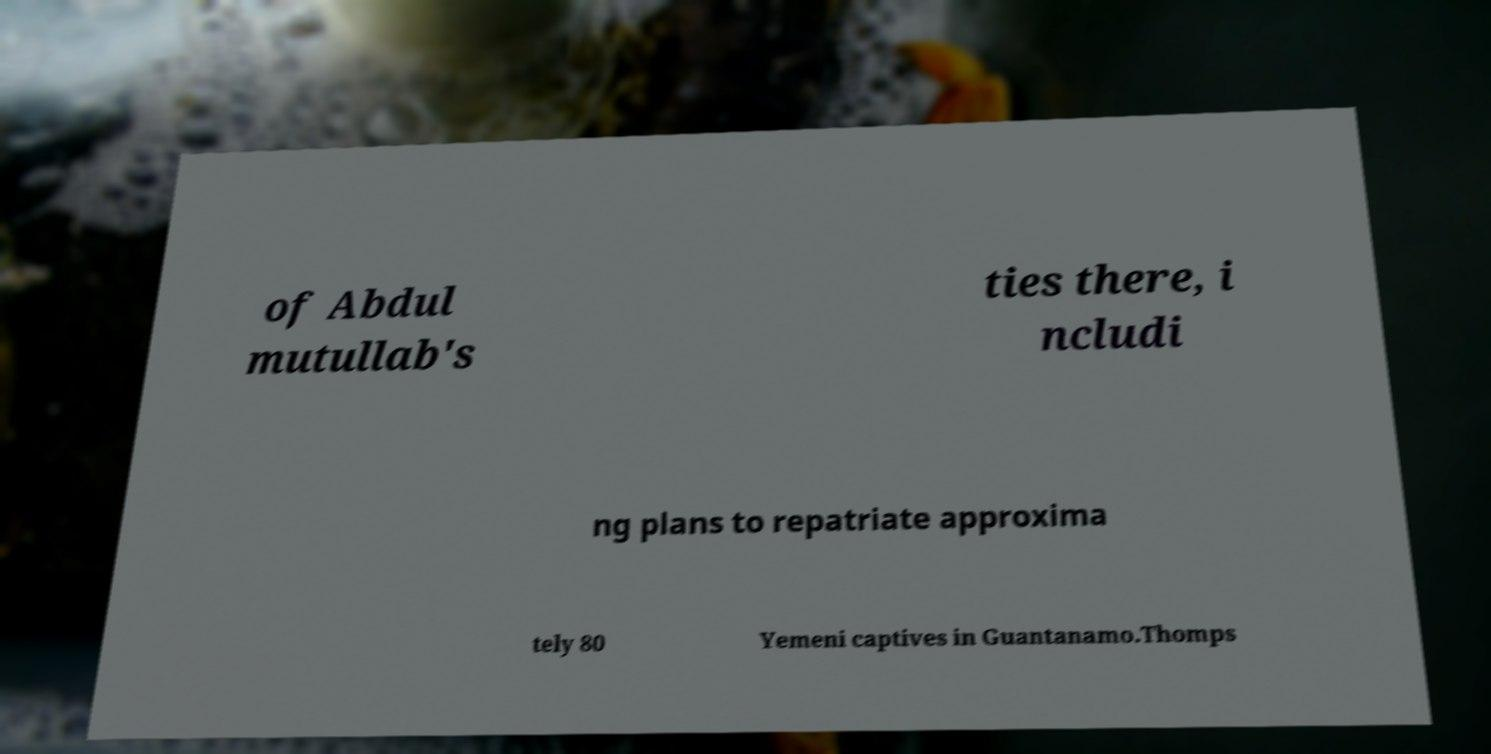Can you accurately transcribe the text from the provided image for me? of Abdul mutullab's ties there, i ncludi ng plans to repatriate approxima tely 80 Yemeni captives in Guantanamo.Thomps 